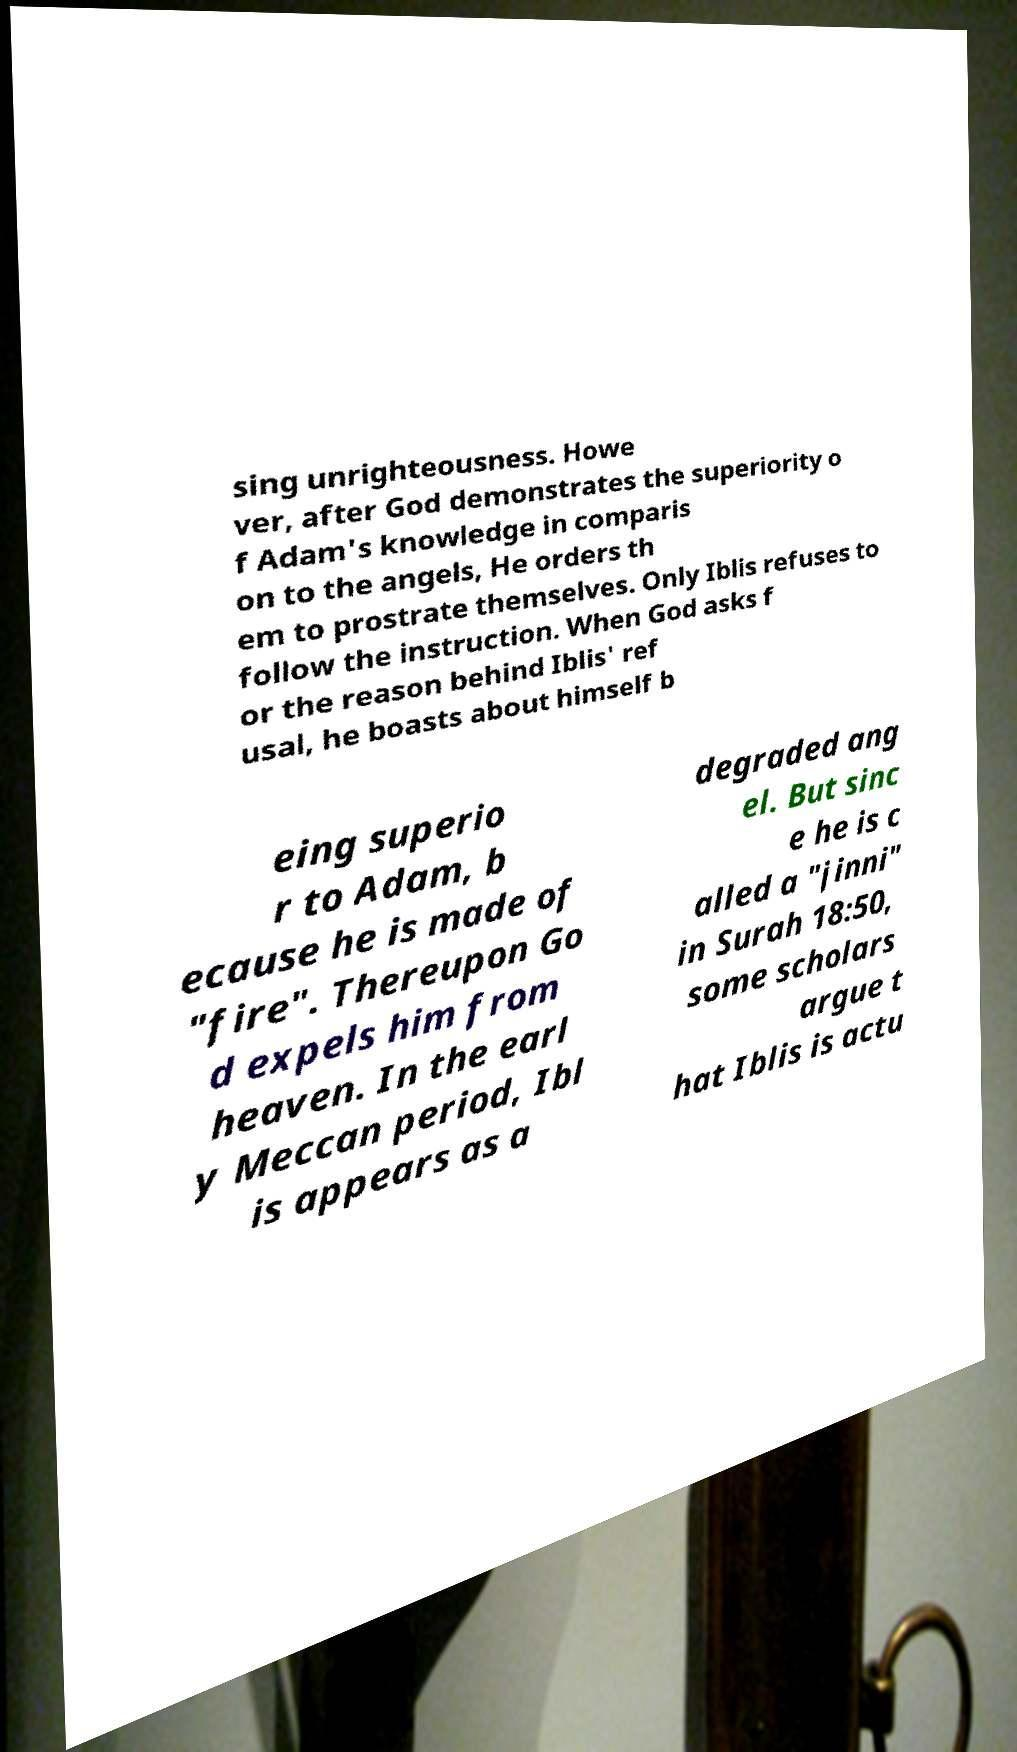Could you extract and type out the text from this image? sing unrighteousness. Howe ver, after God demonstrates the superiority o f Adam's knowledge in comparis on to the angels, He orders th em to prostrate themselves. Only Iblis refuses to follow the instruction. When God asks f or the reason behind Iblis' ref usal, he boasts about himself b eing superio r to Adam, b ecause he is made of "fire". Thereupon Go d expels him from heaven. In the earl y Meccan period, Ibl is appears as a degraded ang el. But sinc e he is c alled a "jinni" in Surah 18:50, some scholars argue t hat Iblis is actu 